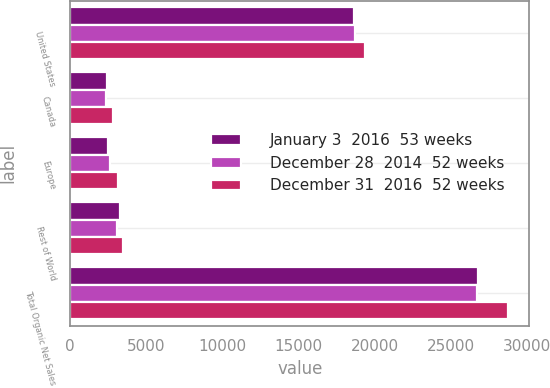Convert chart. <chart><loc_0><loc_0><loc_500><loc_500><stacked_bar_chart><ecel><fcel>United States<fcel>Canada<fcel>Europe<fcel>Rest of World<fcel>Total Organic Net Sales<nl><fcel>January 3  2016  53 weeks<fcel>18641<fcel>2393<fcel>2520<fcel>3263<fcel>26817<nl><fcel>December 28  2014  52 weeks<fcel>18699<fcel>2359<fcel>2588<fcel>3082<fcel>26728<nl><fcel>December 31  2016  52 weeks<fcel>19346<fcel>2811<fcel>3126<fcel>3458<fcel>28741<nl></chart> 